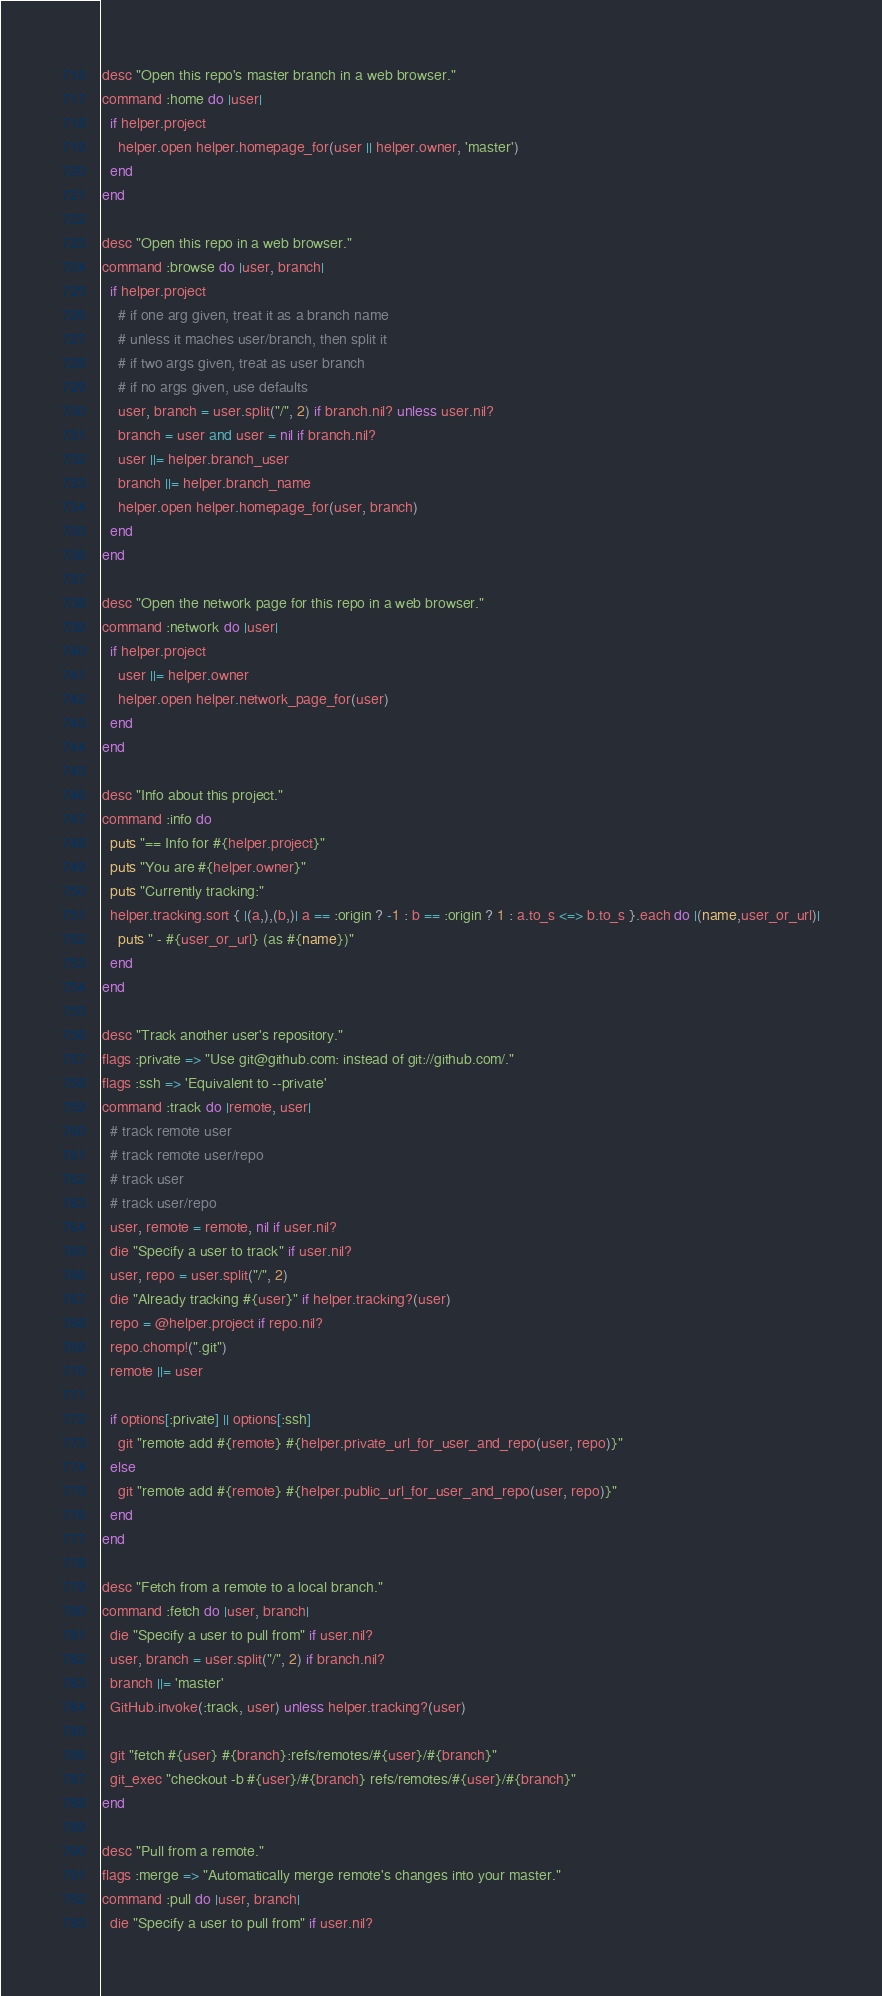Convert code to text. <code><loc_0><loc_0><loc_500><loc_500><_Ruby_>desc "Open this repo's master branch in a web browser."
command :home do |user|
  if helper.project
    helper.open helper.homepage_for(user || helper.owner, 'master')
  end
end

desc "Open this repo in a web browser."
command :browse do |user, branch|
  if helper.project
    # if one arg given, treat it as a branch name
    # unless it maches user/branch, then split it
    # if two args given, treat as user branch
    # if no args given, use defaults
    user, branch = user.split("/", 2) if branch.nil? unless user.nil?
    branch = user and user = nil if branch.nil?
    user ||= helper.branch_user
    branch ||= helper.branch_name
    helper.open helper.homepage_for(user, branch)
  end
end

desc "Open the network page for this repo in a web browser."
command :network do |user|
  if helper.project
    user ||= helper.owner
    helper.open helper.network_page_for(user)
  end
end

desc "Info about this project."
command :info do
  puts "== Info for #{helper.project}"
  puts "You are #{helper.owner}"
  puts "Currently tracking:"
  helper.tracking.sort { |(a,),(b,)| a == :origin ? -1 : b == :origin ? 1 : a.to_s <=> b.to_s }.each do |(name,user_or_url)|
    puts " - #{user_or_url} (as #{name})"
  end
end

desc "Track another user's repository."
flags :private => "Use git@github.com: instead of git://github.com/."
flags :ssh => 'Equivalent to --private'
command :track do |remote, user|
  # track remote user
  # track remote user/repo
  # track user
  # track user/repo
  user, remote = remote, nil if user.nil?
  die "Specify a user to track" if user.nil?
  user, repo = user.split("/", 2)
  die "Already tracking #{user}" if helper.tracking?(user)
  repo = @helper.project if repo.nil?
  repo.chomp!(".git")
  remote ||= user

  if options[:private] || options[:ssh]
    git "remote add #{remote} #{helper.private_url_for_user_and_repo(user, repo)}"
  else
    git "remote add #{remote} #{helper.public_url_for_user_and_repo(user, repo)}"
  end
end

desc "Fetch from a remote to a local branch."
command :fetch do |user, branch|
  die "Specify a user to pull from" if user.nil?
  user, branch = user.split("/", 2) if branch.nil?
  branch ||= 'master'
  GitHub.invoke(:track, user) unless helper.tracking?(user)
  
  git "fetch #{user} #{branch}:refs/remotes/#{user}/#{branch}"
  git_exec "checkout -b #{user}/#{branch} refs/remotes/#{user}/#{branch}"
end

desc "Pull from a remote."
flags :merge => "Automatically merge remote's changes into your master."
command :pull do |user, branch|
  die "Specify a user to pull from" if user.nil?</code> 